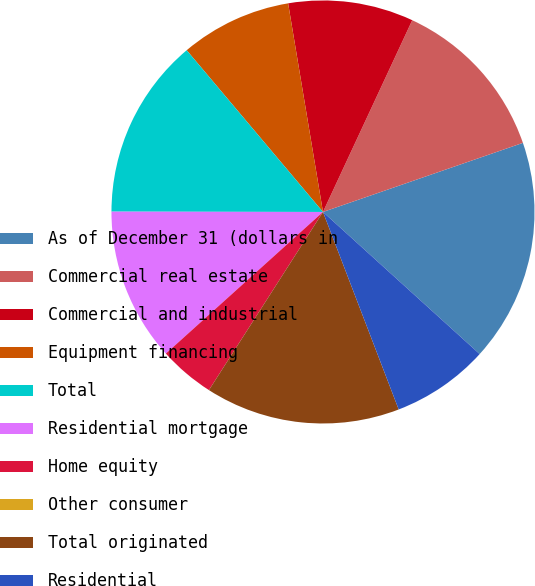<chart> <loc_0><loc_0><loc_500><loc_500><pie_chart><fcel>As of December 31 (dollars in<fcel>Commercial real estate<fcel>Commercial and industrial<fcel>Equipment financing<fcel>Total<fcel>Residential mortgage<fcel>Home equity<fcel>Other consumer<fcel>Total originated<fcel>Residential<nl><fcel>17.02%<fcel>12.77%<fcel>9.57%<fcel>8.51%<fcel>13.83%<fcel>11.7%<fcel>4.26%<fcel>0.0%<fcel>14.89%<fcel>7.45%<nl></chart> 